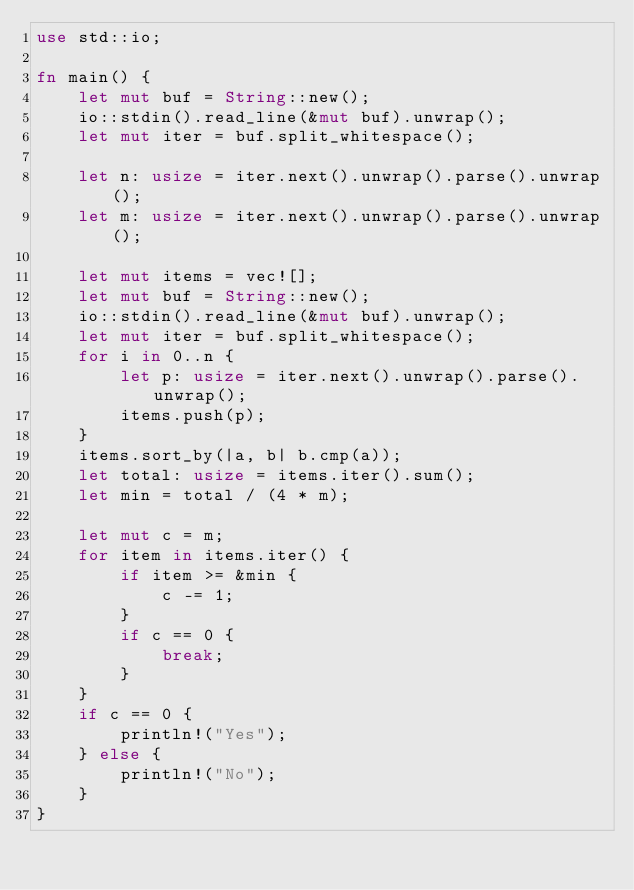<code> <loc_0><loc_0><loc_500><loc_500><_Rust_>use std::io;

fn main() {
    let mut buf = String::new();
    io::stdin().read_line(&mut buf).unwrap();
    let mut iter = buf.split_whitespace();

    let n: usize = iter.next().unwrap().parse().unwrap();
    let m: usize = iter.next().unwrap().parse().unwrap();

    let mut items = vec![];
    let mut buf = String::new();
    io::stdin().read_line(&mut buf).unwrap();
    let mut iter = buf.split_whitespace();
    for i in 0..n {
        let p: usize = iter.next().unwrap().parse().unwrap();
        items.push(p);
    }
    items.sort_by(|a, b| b.cmp(a));
    let total: usize = items.iter().sum();
    let min = total / (4 * m);

    let mut c = m;
    for item in items.iter() {
        if item >= &min {
            c -= 1;
        }
        if c == 0 {
            break;
        }
    }
    if c == 0 {
        println!("Yes");
    } else {
        println!("No");
    }
}
</code> 